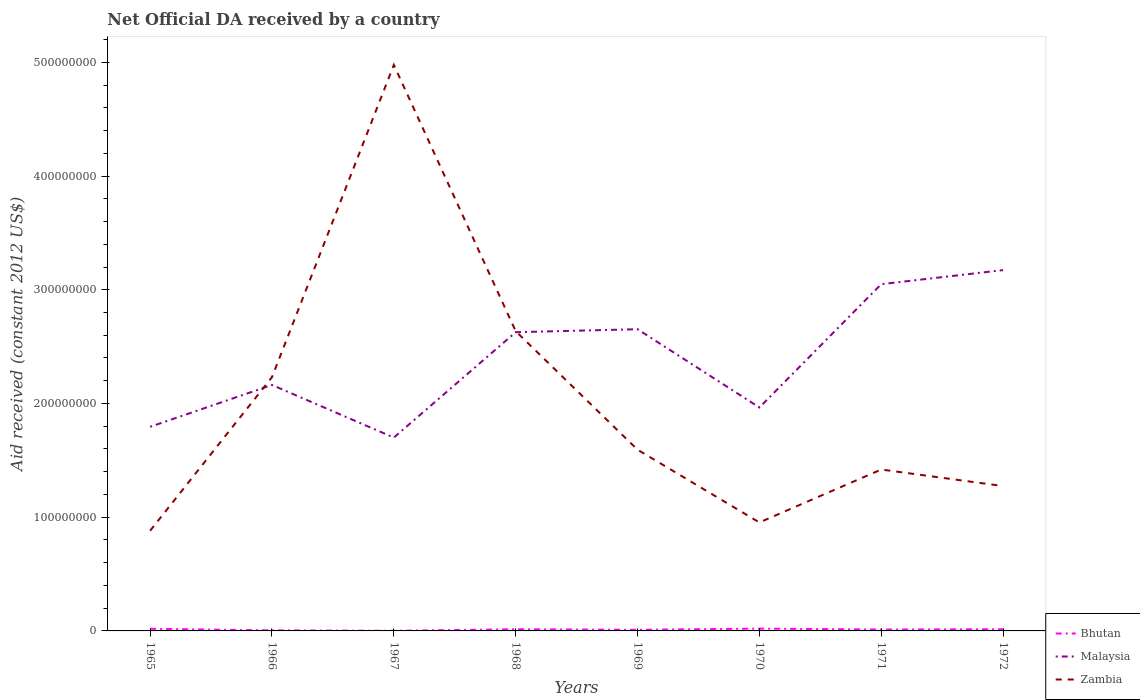Does the line corresponding to Zambia intersect with the line corresponding to Bhutan?
Ensure brevity in your answer.  No. Is the number of lines equal to the number of legend labels?
Make the answer very short. Yes. Across all years, what is the maximum net official development assistance aid received in Malaysia?
Offer a very short reply. 1.70e+08. In which year was the net official development assistance aid received in Zambia maximum?
Ensure brevity in your answer.  1965. What is the total net official development assistance aid received in Zambia in the graph?
Make the answer very short. -4.10e+08. What is the difference between the highest and the second highest net official development assistance aid received in Zambia?
Make the answer very short. 4.10e+08. What is the difference between the highest and the lowest net official development assistance aid received in Zambia?
Provide a succinct answer. 3. How many lines are there?
Ensure brevity in your answer.  3. Are the values on the major ticks of Y-axis written in scientific E-notation?
Ensure brevity in your answer.  No. Does the graph contain any zero values?
Give a very brief answer. No. Where does the legend appear in the graph?
Give a very brief answer. Bottom right. How many legend labels are there?
Provide a short and direct response. 3. What is the title of the graph?
Offer a terse response. Net Official DA received by a country. Does "Cambodia" appear as one of the legend labels in the graph?
Keep it short and to the point. No. What is the label or title of the Y-axis?
Offer a very short reply. Aid received (constant 2012 US$). What is the Aid received (constant 2012 US$) of Bhutan in 1965?
Offer a very short reply. 1.89e+06. What is the Aid received (constant 2012 US$) of Malaysia in 1965?
Give a very brief answer. 1.80e+08. What is the Aid received (constant 2012 US$) of Zambia in 1965?
Your response must be concise. 8.81e+07. What is the Aid received (constant 2012 US$) in Malaysia in 1966?
Provide a succinct answer. 2.16e+08. What is the Aid received (constant 2012 US$) in Zambia in 1966?
Your answer should be compact. 2.23e+08. What is the Aid received (constant 2012 US$) of Malaysia in 1967?
Your answer should be very brief. 1.70e+08. What is the Aid received (constant 2012 US$) in Zambia in 1967?
Ensure brevity in your answer.  4.98e+08. What is the Aid received (constant 2012 US$) in Bhutan in 1968?
Provide a short and direct response. 1.49e+06. What is the Aid received (constant 2012 US$) in Malaysia in 1968?
Keep it short and to the point. 2.63e+08. What is the Aid received (constant 2012 US$) of Zambia in 1968?
Keep it short and to the point. 2.64e+08. What is the Aid received (constant 2012 US$) of Bhutan in 1969?
Your answer should be very brief. 1.01e+06. What is the Aid received (constant 2012 US$) in Malaysia in 1969?
Give a very brief answer. 2.65e+08. What is the Aid received (constant 2012 US$) in Zambia in 1969?
Ensure brevity in your answer.  1.59e+08. What is the Aid received (constant 2012 US$) of Bhutan in 1970?
Your response must be concise. 2.02e+06. What is the Aid received (constant 2012 US$) in Malaysia in 1970?
Provide a short and direct response. 1.96e+08. What is the Aid received (constant 2012 US$) in Zambia in 1970?
Your answer should be compact. 9.54e+07. What is the Aid received (constant 2012 US$) in Bhutan in 1971?
Provide a short and direct response. 1.24e+06. What is the Aid received (constant 2012 US$) of Malaysia in 1971?
Make the answer very short. 3.05e+08. What is the Aid received (constant 2012 US$) of Zambia in 1971?
Your answer should be compact. 1.42e+08. What is the Aid received (constant 2012 US$) in Bhutan in 1972?
Keep it short and to the point. 1.47e+06. What is the Aid received (constant 2012 US$) in Malaysia in 1972?
Your response must be concise. 3.17e+08. What is the Aid received (constant 2012 US$) in Zambia in 1972?
Your response must be concise. 1.27e+08. Across all years, what is the maximum Aid received (constant 2012 US$) of Bhutan?
Give a very brief answer. 2.02e+06. Across all years, what is the maximum Aid received (constant 2012 US$) in Malaysia?
Your response must be concise. 3.17e+08. Across all years, what is the maximum Aid received (constant 2012 US$) in Zambia?
Provide a short and direct response. 4.98e+08. Across all years, what is the minimum Aid received (constant 2012 US$) of Malaysia?
Offer a terse response. 1.70e+08. Across all years, what is the minimum Aid received (constant 2012 US$) of Zambia?
Your answer should be compact. 8.81e+07. What is the total Aid received (constant 2012 US$) in Bhutan in the graph?
Offer a very short reply. 9.73e+06. What is the total Aid received (constant 2012 US$) of Malaysia in the graph?
Offer a terse response. 1.91e+09. What is the total Aid received (constant 2012 US$) of Zambia in the graph?
Keep it short and to the point. 1.60e+09. What is the difference between the Aid received (constant 2012 US$) in Bhutan in 1965 and that in 1966?
Make the answer very short. 1.39e+06. What is the difference between the Aid received (constant 2012 US$) in Malaysia in 1965 and that in 1966?
Your answer should be very brief. -3.68e+07. What is the difference between the Aid received (constant 2012 US$) in Zambia in 1965 and that in 1966?
Your answer should be compact. -1.35e+08. What is the difference between the Aid received (constant 2012 US$) in Bhutan in 1965 and that in 1967?
Give a very brief answer. 1.78e+06. What is the difference between the Aid received (constant 2012 US$) of Malaysia in 1965 and that in 1967?
Offer a very short reply. 9.49e+06. What is the difference between the Aid received (constant 2012 US$) of Zambia in 1965 and that in 1967?
Give a very brief answer. -4.10e+08. What is the difference between the Aid received (constant 2012 US$) of Malaysia in 1965 and that in 1968?
Your response must be concise. -8.32e+07. What is the difference between the Aid received (constant 2012 US$) of Zambia in 1965 and that in 1968?
Keep it short and to the point. -1.75e+08. What is the difference between the Aid received (constant 2012 US$) in Bhutan in 1965 and that in 1969?
Make the answer very short. 8.80e+05. What is the difference between the Aid received (constant 2012 US$) in Malaysia in 1965 and that in 1969?
Offer a terse response. -8.58e+07. What is the difference between the Aid received (constant 2012 US$) of Zambia in 1965 and that in 1969?
Your answer should be compact. -7.12e+07. What is the difference between the Aid received (constant 2012 US$) in Bhutan in 1965 and that in 1970?
Provide a short and direct response. -1.30e+05. What is the difference between the Aid received (constant 2012 US$) in Malaysia in 1965 and that in 1970?
Offer a very short reply. -1.70e+07. What is the difference between the Aid received (constant 2012 US$) of Zambia in 1965 and that in 1970?
Make the answer very short. -7.28e+06. What is the difference between the Aid received (constant 2012 US$) of Bhutan in 1965 and that in 1971?
Provide a short and direct response. 6.50e+05. What is the difference between the Aid received (constant 2012 US$) of Malaysia in 1965 and that in 1971?
Keep it short and to the point. -1.25e+08. What is the difference between the Aid received (constant 2012 US$) in Zambia in 1965 and that in 1971?
Give a very brief answer. -5.38e+07. What is the difference between the Aid received (constant 2012 US$) in Malaysia in 1965 and that in 1972?
Your answer should be compact. -1.38e+08. What is the difference between the Aid received (constant 2012 US$) of Zambia in 1965 and that in 1972?
Your response must be concise. -3.93e+07. What is the difference between the Aid received (constant 2012 US$) in Malaysia in 1966 and that in 1967?
Keep it short and to the point. 4.63e+07. What is the difference between the Aid received (constant 2012 US$) in Zambia in 1966 and that in 1967?
Your answer should be compact. -2.75e+08. What is the difference between the Aid received (constant 2012 US$) of Bhutan in 1966 and that in 1968?
Your answer should be compact. -9.90e+05. What is the difference between the Aid received (constant 2012 US$) in Malaysia in 1966 and that in 1968?
Your response must be concise. -4.64e+07. What is the difference between the Aid received (constant 2012 US$) of Zambia in 1966 and that in 1968?
Give a very brief answer. -4.04e+07. What is the difference between the Aid received (constant 2012 US$) of Bhutan in 1966 and that in 1969?
Your response must be concise. -5.10e+05. What is the difference between the Aid received (constant 2012 US$) of Malaysia in 1966 and that in 1969?
Keep it short and to the point. -4.90e+07. What is the difference between the Aid received (constant 2012 US$) of Zambia in 1966 and that in 1969?
Provide a short and direct response. 6.38e+07. What is the difference between the Aid received (constant 2012 US$) in Bhutan in 1966 and that in 1970?
Your response must be concise. -1.52e+06. What is the difference between the Aid received (constant 2012 US$) in Malaysia in 1966 and that in 1970?
Make the answer very short. 1.98e+07. What is the difference between the Aid received (constant 2012 US$) of Zambia in 1966 and that in 1970?
Ensure brevity in your answer.  1.28e+08. What is the difference between the Aid received (constant 2012 US$) in Bhutan in 1966 and that in 1971?
Offer a terse response. -7.40e+05. What is the difference between the Aid received (constant 2012 US$) in Malaysia in 1966 and that in 1971?
Make the answer very short. -8.86e+07. What is the difference between the Aid received (constant 2012 US$) in Zambia in 1966 and that in 1971?
Provide a short and direct response. 8.12e+07. What is the difference between the Aid received (constant 2012 US$) in Bhutan in 1966 and that in 1972?
Provide a succinct answer. -9.70e+05. What is the difference between the Aid received (constant 2012 US$) in Malaysia in 1966 and that in 1972?
Your answer should be very brief. -1.01e+08. What is the difference between the Aid received (constant 2012 US$) in Zambia in 1966 and that in 1972?
Offer a terse response. 9.58e+07. What is the difference between the Aid received (constant 2012 US$) in Bhutan in 1967 and that in 1968?
Offer a terse response. -1.38e+06. What is the difference between the Aid received (constant 2012 US$) of Malaysia in 1967 and that in 1968?
Keep it short and to the point. -9.27e+07. What is the difference between the Aid received (constant 2012 US$) of Zambia in 1967 and that in 1968?
Your answer should be compact. 2.34e+08. What is the difference between the Aid received (constant 2012 US$) in Bhutan in 1967 and that in 1969?
Your answer should be very brief. -9.00e+05. What is the difference between the Aid received (constant 2012 US$) in Malaysia in 1967 and that in 1969?
Offer a terse response. -9.53e+07. What is the difference between the Aid received (constant 2012 US$) in Zambia in 1967 and that in 1969?
Make the answer very short. 3.38e+08. What is the difference between the Aid received (constant 2012 US$) in Bhutan in 1967 and that in 1970?
Provide a succinct answer. -1.91e+06. What is the difference between the Aid received (constant 2012 US$) in Malaysia in 1967 and that in 1970?
Keep it short and to the point. -2.65e+07. What is the difference between the Aid received (constant 2012 US$) of Zambia in 1967 and that in 1970?
Make the answer very short. 4.02e+08. What is the difference between the Aid received (constant 2012 US$) in Bhutan in 1967 and that in 1971?
Your answer should be very brief. -1.13e+06. What is the difference between the Aid received (constant 2012 US$) in Malaysia in 1967 and that in 1971?
Ensure brevity in your answer.  -1.35e+08. What is the difference between the Aid received (constant 2012 US$) of Zambia in 1967 and that in 1971?
Keep it short and to the point. 3.56e+08. What is the difference between the Aid received (constant 2012 US$) in Bhutan in 1967 and that in 1972?
Your answer should be compact. -1.36e+06. What is the difference between the Aid received (constant 2012 US$) in Malaysia in 1967 and that in 1972?
Your response must be concise. -1.47e+08. What is the difference between the Aid received (constant 2012 US$) of Zambia in 1967 and that in 1972?
Your answer should be compact. 3.70e+08. What is the difference between the Aid received (constant 2012 US$) in Bhutan in 1968 and that in 1969?
Provide a short and direct response. 4.80e+05. What is the difference between the Aid received (constant 2012 US$) of Malaysia in 1968 and that in 1969?
Your answer should be very brief. -2.61e+06. What is the difference between the Aid received (constant 2012 US$) of Zambia in 1968 and that in 1969?
Give a very brief answer. 1.04e+08. What is the difference between the Aid received (constant 2012 US$) in Bhutan in 1968 and that in 1970?
Provide a succinct answer. -5.30e+05. What is the difference between the Aid received (constant 2012 US$) of Malaysia in 1968 and that in 1970?
Offer a very short reply. 6.62e+07. What is the difference between the Aid received (constant 2012 US$) in Zambia in 1968 and that in 1970?
Make the answer very short. 1.68e+08. What is the difference between the Aid received (constant 2012 US$) in Bhutan in 1968 and that in 1971?
Provide a short and direct response. 2.50e+05. What is the difference between the Aid received (constant 2012 US$) in Malaysia in 1968 and that in 1971?
Provide a succinct answer. -4.22e+07. What is the difference between the Aid received (constant 2012 US$) in Zambia in 1968 and that in 1971?
Your answer should be very brief. 1.22e+08. What is the difference between the Aid received (constant 2012 US$) of Malaysia in 1968 and that in 1972?
Provide a short and direct response. -5.46e+07. What is the difference between the Aid received (constant 2012 US$) of Zambia in 1968 and that in 1972?
Provide a short and direct response. 1.36e+08. What is the difference between the Aid received (constant 2012 US$) in Bhutan in 1969 and that in 1970?
Provide a short and direct response. -1.01e+06. What is the difference between the Aid received (constant 2012 US$) in Malaysia in 1969 and that in 1970?
Provide a short and direct response. 6.88e+07. What is the difference between the Aid received (constant 2012 US$) in Zambia in 1969 and that in 1970?
Give a very brief answer. 6.40e+07. What is the difference between the Aid received (constant 2012 US$) of Bhutan in 1969 and that in 1971?
Your answer should be compact. -2.30e+05. What is the difference between the Aid received (constant 2012 US$) in Malaysia in 1969 and that in 1971?
Your answer should be very brief. -3.96e+07. What is the difference between the Aid received (constant 2012 US$) in Zambia in 1969 and that in 1971?
Ensure brevity in your answer.  1.74e+07. What is the difference between the Aid received (constant 2012 US$) in Bhutan in 1969 and that in 1972?
Offer a terse response. -4.60e+05. What is the difference between the Aid received (constant 2012 US$) in Malaysia in 1969 and that in 1972?
Your response must be concise. -5.20e+07. What is the difference between the Aid received (constant 2012 US$) in Zambia in 1969 and that in 1972?
Provide a short and direct response. 3.20e+07. What is the difference between the Aid received (constant 2012 US$) in Bhutan in 1970 and that in 1971?
Ensure brevity in your answer.  7.80e+05. What is the difference between the Aid received (constant 2012 US$) in Malaysia in 1970 and that in 1971?
Offer a very short reply. -1.08e+08. What is the difference between the Aid received (constant 2012 US$) in Zambia in 1970 and that in 1971?
Offer a terse response. -4.65e+07. What is the difference between the Aid received (constant 2012 US$) in Bhutan in 1970 and that in 1972?
Ensure brevity in your answer.  5.50e+05. What is the difference between the Aid received (constant 2012 US$) of Malaysia in 1970 and that in 1972?
Provide a succinct answer. -1.21e+08. What is the difference between the Aid received (constant 2012 US$) of Zambia in 1970 and that in 1972?
Keep it short and to the point. -3.20e+07. What is the difference between the Aid received (constant 2012 US$) of Bhutan in 1971 and that in 1972?
Keep it short and to the point. -2.30e+05. What is the difference between the Aid received (constant 2012 US$) of Malaysia in 1971 and that in 1972?
Your response must be concise. -1.24e+07. What is the difference between the Aid received (constant 2012 US$) in Zambia in 1971 and that in 1972?
Your response must be concise. 1.46e+07. What is the difference between the Aid received (constant 2012 US$) of Bhutan in 1965 and the Aid received (constant 2012 US$) of Malaysia in 1966?
Make the answer very short. -2.14e+08. What is the difference between the Aid received (constant 2012 US$) in Bhutan in 1965 and the Aid received (constant 2012 US$) in Zambia in 1966?
Offer a terse response. -2.21e+08. What is the difference between the Aid received (constant 2012 US$) of Malaysia in 1965 and the Aid received (constant 2012 US$) of Zambia in 1966?
Offer a terse response. -4.37e+07. What is the difference between the Aid received (constant 2012 US$) in Bhutan in 1965 and the Aid received (constant 2012 US$) in Malaysia in 1967?
Make the answer very short. -1.68e+08. What is the difference between the Aid received (constant 2012 US$) of Bhutan in 1965 and the Aid received (constant 2012 US$) of Zambia in 1967?
Give a very brief answer. -4.96e+08. What is the difference between the Aid received (constant 2012 US$) in Malaysia in 1965 and the Aid received (constant 2012 US$) in Zambia in 1967?
Make the answer very short. -3.18e+08. What is the difference between the Aid received (constant 2012 US$) of Bhutan in 1965 and the Aid received (constant 2012 US$) of Malaysia in 1968?
Offer a terse response. -2.61e+08. What is the difference between the Aid received (constant 2012 US$) of Bhutan in 1965 and the Aid received (constant 2012 US$) of Zambia in 1968?
Ensure brevity in your answer.  -2.62e+08. What is the difference between the Aid received (constant 2012 US$) of Malaysia in 1965 and the Aid received (constant 2012 US$) of Zambia in 1968?
Provide a succinct answer. -8.41e+07. What is the difference between the Aid received (constant 2012 US$) in Bhutan in 1965 and the Aid received (constant 2012 US$) in Malaysia in 1969?
Offer a terse response. -2.63e+08. What is the difference between the Aid received (constant 2012 US$) in Bhutan in 1965 and the Aid received (constant 2012 US$) in Zambia in 1969?
Give a very brief answer. -1.57e+08. What is the difference between the Aid received (constant 2012 US$) of Malaysia in 1965 and the Aid received (constant 2012 US$) of Zambia in 1969?
Offer a terse response. 2.02e+07. What is the difference between the Aid received (constant 2012 US$) of Bhutan in 1965 and the Aid received (constant 2012 US$) of Malaysia in 1970?
Offer a very short reply. -1.95e+08. What is the difference between the Aid received (constant 2012 US$) in Bhutan in 1965 and the Aid received (constant 2012 US$) in Zambia in 1970?
Ensure brevity in your answer.  -9.35e+07. What is the difference between the Aid received (constant 2012 US$) in Malaysia in 1965 and the Aid received (constant 2012 US$) in Zambia in 1970?
Keep it short and to the point. 8.41e+07. What is the difference between the Aid received (constant 2012 US$) in Bhutan in 1965 and the Aid received (constant 2012 US$) in Malaysia in 1971?
Offer a terse response. -3.03e+08. What is the difference between the Aid received (constant 2012 US$) in Bhutan in 1965 and the Aid received (constant 2012 US$) in Zambia in 1971?
Offer a very short reply. -1.40e+08. What is the difference between the Aid received (constant 2012 US$) of Malaysia in 1965 and the Aid received (constant 2012 US$) of Zambia in 1971?
Your response must be concise. 3.76e+07. What is the difference between the Aid received (constant 2012 US$) of Bhutan in 1965 and the Aid received (constant 2012 US$) of Malaysia in 1972?
Your answer should be very brief. -3.15e+08. What is the difference between the Aid received (constant 2012 US$) in Bhutan in 1965 and the Aid received (constant 2012 US$) in Zambia in 1972?
Make the answer very short. -1.25e+08. What is the difference between the Aid received (constant 2012 US$) of Malaysia in 1965 and the Aid received (constant 2012 US$) of Zambia in 1972?
Your answer should be compact. 5.21e+07. What is the difference between the Aid received (constant 2012 US$) in Bhutan in 1966 and the Aid received (constant 2012 US$) in Malaysia in 1967?
Provide a short and direct response. -1.70e+08. What is the difference between the Aid received (constant 2012 US$) in Bhutan in 1966 and the Aid received (constant 2012 US$) in Zambia in 1967?
Make the answer very short. -4.97e+08. What is the difference between the Aid received (constant 2012 US$) of Malaysia in 1966 and the Aid received (constant 2012 US$) of Zambia in 1967?
Keep it short and to the point. -2.81e+08. What is the difference between the Aid received (constant 2012 US$) in Bhutan in 1966 and the Aid received (constant 2012 US$) in Malaysia in 1968?
Your answer should be compact. -2.62e+08. What is the difference between the Aid received (constant 2012 US$) in Bhutan in 1966 and the Aid received (constant 2012 US$) in Zambia in 1968?
Your answer should be very brief. -2.63e+08. What is the difference between the Aid received (constant 2012 US$) in Malaysia in 1966 and the Aid received (constant 2012 US$) in Zambia in 1968?
Offer a terse response. -4.73e+07. What is the difference between the Aid received (constant 2012 US$) of Bhutan in 1966 and the Aid received (constant 2012 US$) of Malaysia in 1969?
Offer a terse response. -2.65e+08. What is the difference between the Aid received (constant 2012 US$) in Bhutan in 1966 and the Aid received (constant 2012 US$) in Zambia in 1969?
Offer a very short reply. -1.59e+08. What is the difference between the Aid received (constant 2012 US$) in Malaysia in 1966 and the Aid received (constant 2012 US$) in Zambia in 1969?
Make the answer very short. 5.69e+07. What is the difference between the Aid received (constant 2012 US$) of Bhutan in 1966 and the Aid received (constant 2012 US$) of Malaysia in 1970?
Give a very brief answer. -1.96e+08. What is the difference between the Aid received (constant 2012 US$) of Bhutan in 1966 and the Aid received (constant 2012 US$) of Zambia in 1970?
Your response must be concise. -9.49e+07. What is the difference between the Aid received (constant 2012 US$) of Malaysia in 1966 and the Aid received (constant 2012 US$) of Zambia in 1970?
Provide a short and direct response. 1.21e+08. What is the difference between the Aid received (constant 2012 US$) in Bhutan in 1966 and the Aid received (constant 2012 US$) in Malaysia in 1971?
Ensure brevity in your answer.  -3.04e+08. What is the difference between the Aid received (constant 2012 US$) of Bhutan in 1966 and the Aid received (constant 2012 US$) of Zambia in 1971?
Your answer should be compact. -1.41e+08. What is the difference between the Aid received (constant 2012 US$) of Malaysia in 1966 and the Aid received (constant 2012 US$) of Zambia in 1971?
Your response must be concise. 7.44e+07. What is the difference between the Aid received (constant 2012 US$) in Bhutan in 1966 and the Aid received (constant 2012 US$) in Malaysia in 1972?
Offer a terse response. -3.17e+08. What is the difference between the Aid received (constant 2012 US$) of Bhutan in 1966 and the Aid received (constant 2012 US$) of Zambia in 1972?
Give a very brief answer. -1.27e+08. What is the difference between the Aid received (constant 2012 US$) in Malaysia in 1966 and the Aid received (constant 2012 US$) in Zambia in 1972?
Your answer should be compact. 8.89e+07. What is the difference between the Aid received (constant 2012 US$) in Bhutan in 1967 and the Aid received (constant 2012 US$) in Malaysia in 1968?
Provide a succinct answer. -2.63e+08. What is the difference between the Aid received (constant 2012 US$) in Bhutan in 1967 and the Aid received (constant 2012 US$) in Zambia in 1968?
Offer a terse response. -2.63e+08. What is the difference between the Aid received (constant 2012 US$) of Malaysia in 1967 and the Aid received (constant 2012 US$) of Zambia in 1968?
Make the answer very short. -9.36e+07. What is the difference between the Aid received (constant 2012 US$) of Bhutan in 1967 and the Aid received (constant 2012 US$) of Malaysia in 1969?
Your response must be concise. -2.65e+08. What is the difference between the Aid received (constant 2012 US$) of Bhutan in 1967 and the Aid received (constant 2012 US$) of Zambia in 1969?
Make the answer very short. -1.59e+08. What is the difference between the Aid received (constant 2012 US$) in Malaysia in 1967 and the Aid received (constant 2012 US$) in Zambia in 1969?
Your answer should be very brief. 1.07e+07. What is the difference between the Aid received (constant 2012 US$) in Bhutan in 1967 and the Aid received (constant 2012 US$) in Malaysia in 1970?
Provide a short and direct response. -1.96e+08. What is the difference between the Aid received (constant 2012 US$) of Bhutan in 1967 and the Aid received (constant 2012 US$) of Zambia in 1970?
Your response must be concise. -9.53e+07. What is the difference between the Aid received (constant 2012 US$) of Malaysia in 1967 and the Aid received (constant 2012 US$) of Zambia in 1970?
Give a very brief answer. 7.46e+07. What is the difference between the Aid received (constant 2012 US$) of Bhutan in 1967 and the Aid received (constant 2012 US$) of Malaysia in 1971?
Keep it short and to the point. -3.05e+08. What is the difference between the Aid received (constant 2012 US$) of Bhutan in 1967 and the Aid received (constant 2012 US$) of Zambia in 1971?
Give a very brief answer. -1.42e+08. What is the difference between the Aid received (constant 2012 US$) in Malaysia in 1967 and the Aid received (constant 2012 US$) in Zambia in 1971?
Your answer should be very brief. 2.81e+07. What is the difference between the Aid received (constant 2012 US$) of Bhutan in 1967 and the Aid received (constant 2012 US$) of Malaysia in 1972?
Provide a succinct answer. -3.17e+08. What is the difference between the Aid received (constant 2012 US$) in Bhutan in 1967 and the Aid received (constant 2012 US$) in Zambia in 1972?
Your answer should be compact. -1.27e+08. What is the difference between the Aid received (constant 2012 US$) in Malaysia in 1967 and the Aid received (constant 2012 US$) in Zambia in 1972?
Make the answer very short. 4.26e+07. What is the difference between the Aid received (constant 2012 US$) of Bhutan in 1968 and the Aid received (constant 2012 US$) of Malaysia in 1969?
Ensure brevity in your answer.  -2.64e+08. What is the difference between the Aid received (constant 2012 US$) in Bhutan in 1968 and the Aid received (constant 2012 US$) in Zambia in 1969?
Your answer should be compact. -1.58e+08. What is the difference between the Aid received (constant 2012 US$) of Malaysia in 1968 and the Aid received (constant 2012 US$) of Zambia in 1969?
Your answer should be very brief. 1.03e+08. What is the difference between the Aid received (constant 2012 US$) of Bhutan in 1968 and the Aid received (constant 2012 US$) of Malaysia in 1970?
Your answer should be very brief. -1.95e+08. What is the difference between the Aid received (constant 2012 US$) of Bhutan in 1968 and the Aid received (constant 2012 US$) of Zambia in 1970?
Offer a terse response. -9.39e+07. What is the difference between the Aid received (constant 2012 US$) in Malaysia in 1968 and the Aid received (constant 2012 US$) in Zambia in 1970?
Offer a very short reply. 1.67e+08. What is the difference between the Aid received (constant 2012 US$) in Bhutan in 1968 and the Aid received (constant 2012 US$) in Malaysia in 1971?
Ensure brevity in your answer.  -3.03e+08. What is the difference between the Aid received (constant 2012 US$) in Bhutan in 1968 and the Aid received (constant 2012 US$) in Zambia in 1971?
Ensure brevity in your answer.  -1.40e+08. What is the difference between the Aid received (constant 2012 US$) in Malaysia in 1968 and the Aid received (constant 2012 US$) in Zambia in 1971?
Offer a terse response. 1.21e+08. What is the difference between the Aid received (constant 2012 US$) in Bhutan in 1968 and the Aid received (constant 2012 US$) in Malaysia in 1972?
Give a very brief answer. -3.16e+08. What is the difference between the Aid received (constant 2012 US$) in Bhutan in 1968 and the Aid received (constant 2012 US$) in Zambia in 1972?
Keep it short and to the point. -1.26e+08. What is the difference between the Aid received (constant 2012 US$) in Malaysia in 1968 and the Aid received (constant 2012 US$) in Zambia in 1972?
Offer a terse response. 1.35e+08. What is the difference between the Aid received (constant 2012 US$) of Bhutan in 1969 and the Aid received (constant 2012 US$) of Malaysia in 1970?
Make the answer very short. -1.95e+08. What is the difference between the Aid received (constant 2012 US$) of Bhutan in 1969 and the Aid received (constant 2012 US$) of Zambia in 1970?
Offer a very short reply. -9.44e+07. What is the difference between the Aid received (constant 2012 US$) of Malaysia in 1969 and the Aid received (constant 2012 US$) of Zambia in 1970?
Give a very brief answer. 1.70e+08. What is the difference between the Aid received (constant 2012 US$) of Bhutan in 1969 and the Aid received (constant 2012 US$) of Malaysia in 1971?
Your answer should be very brief. -3.04e+08. What is the difference between the Aid received (constant 2012 US$) in Bhutan in 1969 and the Aid received (constant 2012 US$) in Zambia in 1971?
Provide a succinct answer. -1.41e+08. What is the difference between the Aid received (constant 2012 US$) in Malaysia in 1969 and the Aid received (constant 2012 US$) in Zambia in 1971?
Offer a terse response. 1.23e+08. What is the difference between the Aid received (constant 2012 US$) in Bhutan in 1969 and the Aid received (constant 2012 US$) in Malaysia in 1972?
Keep it short and to the point. -3.16e+08. What is the difference between the Aid received (constant 2012 US$) in Bhutan in 1969 and the Aid received (constant 2012 US$) in Zambia in 1972?
Keep it short and to the point. -1.26e+08. What is the difference between the Aid received (constant 2012 US$) in Malaysia in 1969 and the Aid received (constant 2012 US$) in Zambia in 1972?
Keep it short and to the point. 1.38e+08. What is the difference between the Aid received (constant 2012 US$) of Bhutan in 1970 and the Aid received (constant 2012 US$) of Malaysia in 1971?
Make the answer very short. -3.03e+08. What is the difference between the Aid received (constant 2012 US$) of Bhutan in 1970 and the Aid received (constant 2012 US$) of Zambia in 1971?
Provide a short and direct response. -1.40e+08. What is the difference between the Aid received (constant 2012 US$) in Malaysia in 1970 and the Aid received (constant 2012 US$) in Zambia in 1971?
Provide a short and direct response. 5.46e+07. What is the difference between the Aid received (constant 2012 US$) of Bhutan in 1970 and the Aid received (constant 2012 US$) of Malaysia in 1972?
Provide a short and direct response. -3.15e+08. What is the difference between the Aid received (constant 2012 US$) of Bhutan in 1970 and the Aid received (constant 2012 US$) of Zambia in 1972?
Your response must be concise. -1.25e+08. What is the difference between the Aid received (constant 2012 US$) in Malaysia in 1970 and the Aid received (constant 2012 US$) in Zambia in 1972?
Keep it short and to the point. 6.91e+07. What is the difference between the Aid received (constant 2012 US$) in Bhutan in 1971 and the Aid received (constant 2012 US$) in Malaysia in 1972?
Give a very brief answer. -3.16e+08. What is the difference between the Aid received (constant 2012 US$) in Bhutan in 1971 and the Aid received (constant 2012 US$) in Zambia in 1972?
Your response must be concise. -1.26e+08. What is the difference between the Aid received (constant 2012 US$) in Malaysia in 1971 and the Aid received (constant 2012 US$) in Zambia in 1972?
Give a very brief answer. 1.78e+08. What is the average Aid received (constant 2012 US$) of Bhutan per year?
Ensure brevity in your answer.  1.22e+06. What is the average Aid received (constant 2012 US$) in Malaysia per year?
Ensure brevity in your answer.  2.39e+08. What is the average Aid received (constant 2012 US$) in Zambia per year?
Provide a succinct answer. 2.00e+08. In the year 1965, what is the difference between the Aid received (constant 2012 US$) in Bhutan and Aid received (constant 2012 US$) in Malaysia?
Ensure brevity in your answer.  -1.78e+08. In the year 1965, what is the difference between the Aid received (constant 2012 US$) of Bhutan and Aid received (constant 2012 US$) of Zambia?
Make the answer very short. -8.62e+07. In the year 1965, what is the difference between the Aid received (constant 2012 US$) of Malaysia and Aid received (constant 2012 US$) of Zambia?
Provide a succinct answer. 9.14e+07. In the year 1966, what is the difference between the Aid received (constant 2012 US$) of Bhutan and Aid received (constant 2012 US$) of Malaysia?
Provide a succinct answer. -2.16e+08. In the year 1966, what is the difference between the Aid received (constant 2012 US$) of Bhutan and Aid received (constant 2012 US$) of Zambia?
Give a very brief answer. -2.23e+08. In the year 1966, what is the difference between the Aid received (constant 2012 US$) in Malaysia and Aid received (constant 2012 US$) in Zambia?
Keep it short and to the point. -6.89e+06. In the year 1967, what is the difference between the Aid received (constant 2012 US$) of Bhutan and Aid received (constant 2012 US$) of Malaysia?
Keep it short and to the point. -1.70e+08. In the year 1967, what is the difference between the Aid received (constant 2012 US$) of Bhutan and Aid received (constant 2012 US$) of Zambia?
Provide a short and direct response. -4.98e+08. In the year 1967, what is the difference between the Aid received (constant 2012 US$) in Malaysia and Aid received (constant 2012 US$) in Zambia?
Give a very brief answer. -3.28e+08. In the year 1968, what is the difference between the Aid received (constant 2012 US$) of Bhutan and Aid received (constant 2012 US$) of Malaysia?
Give a very brief answer. -2.61e+08. In the year 1968, what is the difference between the Aid received (constant 2012 US$) of Bhutan and Aid received (constant 2012 US$) of Zambia?
Your answer should be very brief. -2.62e+08. In the year 1968, what is the difference between the Aid received (constant 2012 US$) in Malaysia and Aid received (constant 2012 US$) in Zambia?
Provide a succinct answer. -8.90e+05. In the year 1969, what is the difference between the Aid received (constant 2012 US$) of Bhutan and Aid received (constant 2012 US$) of Malaysia?
Ensure brevity in your answer.  -2.64e+08. In the year 1969, what is the difference between the Aid received (constant 2012 US$) of Bhutan and Aid received (constant 2012 US$) of Zambia?
Your response must be concise. -1.58e+08. In the year 1969, what is the difference between the Aid received (constant 2012 US$) of Malaysia and Aid received (constant 2012 US$) of Zambia?
Make the answer very short. 1.06e+08. In the year 1970, what is the difference between the Aid received (constant 2012 US$) of Bhutan and Aid received (constant 2012 US$) of Malaysia?
Make the answer very short. -1.94e+08. In the year 1970, what is the difference between the Aid received (constant 2012 US$) of Bhutan and Aid received (constant 2012 US$) of Zambia?
Offer a very short reply. -9.34e+07. In the year 1970, what is the difference between the Aid received (constant 2012 US$) of Malaysia and Aid received (constant 2012 US$) of Zambia?
Give a very brief answer. 1.01e+08. In the year 1971, what is the difference between the Aid received (constant 2012 US$) of Bhutan and Aid received (constant 2012 US$) of Malaysia?
Provide a short and direct response. -3.04e+08. In the year 1971, what is the difference between the Aid received (constant 2012 US$) in Bhutan and Aid received (constant 2012 US$) in Zambia?
Offer a terse response. -1.41e+08. In the year 1971, what is the difference between the Aid received (constant 2012 US$) of Malaysia and Aid received (constant 2012 US$) of Zambia?
Offer a very short reply. 1.63e+08. In the year 1972, what is the difference between the Aid received (constant 2012 US$) of Bhutan and Aid received (constant 2012 US$) of Malaysia?
Provide a succinct answer. -3.16e+08. In the year 1972, what is the difference between the Aid received (constant 2012 US$) in Bhutan and Aid received (constant 2012 US$) in Zambia?
Your response must be concise. -1.26e+08. In the year 1972, what is the difference between the Aid received (constant 2012 US$) of Malaysia and Aid received (constant 2012 US$) of Zambia?
Provide a succinct answer. 1.90e+08. What is the ratio of the Aid received (constant 2012 US$) of Bhutan in 1965 to that in 1966?
Provide a succinct answer. 3.78. What is the ratio of the Aid received (constant 2012 US$) of Malaysia in 1965 to that in 1966?
Offer a very short reply. 0.83. What is the ratio of the Aid received (constant 2012 US$) in Zambia in 1965 to that in 1966?
Keep it short and to the point. 0.39. What is the ratio of the Aid received (constant 2012 US$) in Bhutan in 1965 to that in 1967?
Your response must be concise. 17.18. What is the ratio of the Aid received (constant 2012 US$) in Malaysia in 1965 to that in 1967?
Make the answer very short. 1.06. What is the ratio of the Aid received (constant 2012 US$) in Zambia in 1965 to that in 1967?
Ensure brevity in your answer.  0.18. What is the ratio of the Aid received (constant 2012 US$) of Bhutan in 1965 to that in 1968?
Your answer should be very brief. 1.27. What is the ratio of the Aid received (constant 2012 US$) of Malaysia in 1965 to that in 1968?
Offer a terse response. 0.68. What is the ratio of the Aid received (constant 2012 US$) of Zambia in 1965 to that in 1968?
Keep it short and to the point. 0.33. What is the ratio of the Aid received (constant 2012 US$) in Bhutan in 1965 to that in 1969?
Your answer should be compact. 1.87. What is the ratio of the Aid received (constant 2012 US$) in Malaysia in 1965 to that in 1969?
Your response must be concise. 0.68. What is the ratio of the Aid received (constant 2012 US$) of Zambia in 1965 to that in 1969?
Your answer should be very brief. 0.55. What is the ratio of the Aid received (constant 2012 US$) of Bhutan in 1965 to that in 1970?
Provide a short and direct response. 0.94. What is the ratio of the Aid received (constant 2012 US$) of Malaysia in 1965 to that in 1970?
Your answer should be very brief. 0.91. What is the ratio of the Aid received (constant 2012 US$) in Zambia in 1965 to that in 1970?
Offer a very short reply. 0.92. What is the ratio of the Aid received (constant 2012 US$) in Bhutan in 1965 to that in 1971?
Give a very brief answer. 1.52. What is the ratio of the Aid received (constant 2012 US$) in Malaysia in 1965 to that in 1971?
Your answer should be very brief. 0.59. What is the ratio of the Aid received (constant 2012 US$) in Zambia in 1965 to that in 1971?
Keep it short and to the point. 0.62. What is the ratio of the Aid received (constant 2012 US$) of Malaysia in 1965 to that in 1972?
Your answer should be very brief. 0.57. What is the ratio of the Aid received (constant 2012 US$) of Zambia in 1965 to that in 1972?
Offer a terse response. 0.69. What is the ratio of the Aid received (constant 2012 US$) in Bhutan in 1966 to that in 1967?
Provide a short and direct response. 4.55. What is the ratio of the Aid received (constant 2012 US$) in Malaysia in 1966 to that in 1967?
Offer a very short reply. 1.27. What is the ratio of the Aid received (constant 2012 US$) of Zambia in 1966 to that in 1967?
Offer a terse response. 0.45. What is the ratio of the Aid received (constant 2012 US$) of Bhutan in 1966 to that in 1968?
Make the answer very short. 0.34. What is the ratio of the Aid received (constant 2012 US$) of Malaysia in 1966 to that in 1968?
Offer a very short reply. 0.82. What is the ratio of the Aid received (constant 2012 US$) of Zambia in 1966 to that in 1968?
Ensure brevity in your answer.  0.85. What is the ratio of the Aid received (constant 2012 US$) in Bhutan in 1966 to that in 1969?
Make the answer very short. 0.49. What is the ratio of the Aid received (constant 2012 US$) of Malaysia in 1966 to that in 1969?
Offer a very short reply. 0.82. What is the ratio of the Aid received (constant 2012 US$) in Zambia in 1966 to that in 1969?
Provide a succinct answer. 1.4. What is the ratio of the Aid received (constant 2012 US$) in Bhutan in 1966 to that in 1970?
Ensure brevity in your answer.  0.25. What is the ratio of the Aid received (constant 2012 US$) in Malaysia in 1966 to that in 1970?
Make the answer very short. 1.1. What is the ratio of the Aid received (constant 2012 US$) in Zambia in 1966 to that in 1970?
Offer a very short reply. 2.34. What is the ratio of the Aid received (constant 2012 US$) of Bhutan in 1966 to that in 1971?
Provide a short and direct response. 0.4. What is the ratio of the Aid received (constant 2012 US$) of Malaysia in 1966 to that in 1971?
Provide a succinct answer. 0.71. What is the ratio of the Aid received (constant 2012 US$) in Zambia in 1966 to that in 1971?
Your answer should be compact. 1.57. What is the ratio of the Aid received (constant 2012 US$) of Bhutan in 1966 to that in 1972?
Make the answer very short. 0.34. What is the ratio of the Aid received (constant 2012 US$) of Malaysia in 1966 to that in 1972?
Keep it short and to the point. 0.68. What is the ratio of the Aid received (constant 2012 US$) of Zambia in 1966 to that in 1972?
Make the answer very short. 1.75. What is the ratio of the Aid received (constant 2012 US$) of Bhutan in 1967 to that in 1968?
Provide a succinct answer. 0.07. What is the ratio of the Aid received (constant 2012 US$) in Malaysia in 1967 to that in 1968?
Ensure brevity in your answer.  0.65. What is the ratio of the Aid received (constant 2012 US$) in Zambia in 1967 to that in 1968?
Provide a succinct answer. 1.89. What is the ratio of the Aid received (constant 2012 US$) in Bhutan in 1967 to that in 1969?
Your answer should be compact. 0.11. What is the ratio of the Aid received (constant 2012 US$) of Malaysia in 1967 to that in 1969?
Your response must be concise. 0.64. What is the ratio of the Aid received (constant 2012 US$) in Zambia in 1967 to that in 1969?
Offer a very short reply. 3.12. What is the ratio of the Aid received (constant 2012 US$) of Bhutan in 1967 to that in 1970?
Keep it short and to the point. 0.05. What is the ratio of the Aid received (constant 2012 US$) in Malaysia in 1967 to that in 1970?
Your response must be concise. 0.87. What is the ratio of the Aid received (constant 2012 US$) of Zambia in 1967 to that in 1970?
Make the answer very short. 5.22. What is the ratio of the Aid received (constant 2012 US$) of Bhutan in 1967 to that in 1971?
Provide a succinct answer. 0.09. What is the ratio of the Aid received (constant 2012 US$) in Malaysia in 1967 to that in 1971?
Offer a terse response. 0.56. What is the ratio of the Aid received (constant 2012 US$) in Zambia in 1967 to that in 1971?
Provide a succinct answer. 3.51. What is the ratio of the Aid received (constant 2012 US$) of Bhutan in 1967 to that in 1972?
Give a very brief answer. 0.07. What is the ratio of the Aid received (constant 2012 US$) in Malaysia in 1967 to that in 1972?
Offer a terse response. 0.54. What is the ratio of the Aid received (constant 2012 US$) of Zambia in 1967 to that in 1972?
Offer a very short reply. 3.91. What is the ratio of the Aid received (constant 2012 US$) of Bhutan in 1968 to that in 1969?
Offer a terse response. 1.48. What is the ratio of the Aid received (constant 2012 US$) in Malaysia in 1968 to that in 1969?
Your response must be concise. 0.99. What is the ratio of the Aid received (constant 2012 US$) of Zambia in 1968 to that in 1969?
Ensure brevity in your answer.  1.65. What is the ratio of the Aid received (constant 2012 US$) in Bhutan in 1968 to that in 1970?
Keep it short and to the point. 0.74. What is the ratio of the Aid received (constant 2012 US$) of Malaysia in 1968 to that in 1970?
Give a very brief answer. 1.34. What is the ratio of the Aid received (constant 2012 US$) in Zambia in 1968 to that in 1970?
Provide a short and direct response. 2.76. What is the ratio of the Aid received (constant 2012 US$) in Bhutan in 1968 to that in 1971?
Keep it short and to the point. 1.2. What is the ratio of the Aid received (constant 2012 US$) of Malaysia in 1968 to that in 1971?
Ensure brevity in your answer.  0.86. What is the ratio of the Aid received (constant 2012 US$) in Zambia in 1968 to that in 1971?
Offer a very short reply. 1.86. What is the ratio of the Aid received (constant 2012 US$) of Bhutan in 1968 to that in 1972?
Your response must be concise. 1.01. What is the ratio of the Aid received (constant 2012 US$) in Malaysia in 1968 to that in 1972?
Your response must be concise. 0.83. What is the ratio of the Aid received (constant 2012 US$) of Zambia in 1968 to that in 1972?
Your response must be concise. 2.07. What is the ratio of the Aid received (constant 2012 US$) of Bhutan in 1969 to that in 1970?
Offer a terse response. 0.5. What is the ratio of the Aid received (constant 2012 US$) in Malaysia in 1969 to that in 1970?
Your answer should be compact. 1.35. What is the ratio of the Aid received (constant 2012 US$) of Zambia in 1969 to that in 1970?
Provide a succinct answer. 1.67. What is the ratio of the Aid received (constant 2012 US$) of Bhutan in 1969 to that in 1971?
Make the answer very short. 0.81. What is the ratio of the Aid received (constant 2012 US$) of Malaysia in 1969 to that in 1971?
Your answer should be very brief. 0.87. What is the ratio of the Aid received (constant 2012 US$) in Zambia in 1969 to that in 1971?
Offer a very short reply. 1.12. What is the ratio of the Aid received (constant 2012 US$) in Bhutan in 1969 to that in 1972?
Make the answer very short. 0.69. What is the ratio of the Aid received (constant 2012 US$) of Malaysia in 1969 to that in 1972?
Make the answer very short. 0.84. What is the ratio of the Aid received (constant 2012 US$) of Zambia in 1969 to that in 1972?
Keep it short and to the point. 1.25. What is the ratio of the Aid received (constant 2012 US$) of Bhutan in 1970 to that in 1971?
Ensure brevity in your answer.  1.63. What is the ratio of the Aid received (constant 2012 US$) in Malaysia in 1970 to that in 1971?
Your answer should be very brief. 0.64. What is the ratio of the Aid received (constant 2012 US$) of Zambia in 1970 to that in 1971?
Provide a short and direct response. 0.67. What is the ratio of the Aid received (constant 2012 US$) in Bhutan in 1970 to that in 1972?
Make the answer very short. 1.37. What is the ratio of the Aid received (constant 2012 US$) in Malaysia in 1970 to that in 1972?
Your answer should be compact. 0.62. What is the ratio of the Aid received (constant 2012 US$) of Zambia in 1970 to that in 1972?
Keep it short and to the point. 0.75. What is the ratio of the Aid received (constant 2012 US$) of Bhutan in 1971 to that in 1972?
Make the answer very short. 0.84. What is the ratio of the Aid received (constant 2012 US$) in Malaysia in 1971 to that in 1972?
Offer a terse response. 0.96. What is the ratio of the Aid received (constant 2012 US$) in Zambia in 1971 to that in 1972?
Keep it short and to the point. 1.11. What is the difference between the highest and the second highest Aid received (constant 2012 US$) of Bhutan?
Your answer should be compact. 1.30e+05. What is the difference between the highest and the second highest Aid received (constant 2012 US$) in Malaysia?
Your answer should be very brief. 1.24e+07. What is the difference between the highest and the second highest Aid received (constant 2012 US$) of Zambia?
Provide a short and direct response. 2.34e+08. What is the difference between the highest and the lowest Aid received (constant 2012 US$) of Bhutan?
Your response must be concise. 1.91e+06. What is the difference between the highest and the lowest Aid received (constant 2012 US$) in Malaysia?
Provide a succinct answer. 1.47e+08. What is the difference between the highest and the lowest Aid received (constant 2012 US$) in Zambia?
Your answer should be compact. 4.10e+08. 